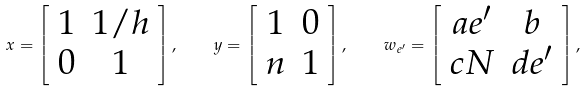Convert formula to latex. <formula><loc_0><loc_0><loc_500><loc_500>x = \left [ \begin{array} { c c } 1 & 1 / h \\ 0 & 1 \\ \end{array} \right ] , \quad y = \left [ \begin{array} { c c } 1 & 0 \\ n & 1 \\ \end{array} \right ] , \quad w _ { e ^ { \prime } } = \left [ \begin{array} { c c } a e ^ { \prime } & b \\ c N & d e ^ { \prime } \\ \end{array} \right ] ,</formula> 